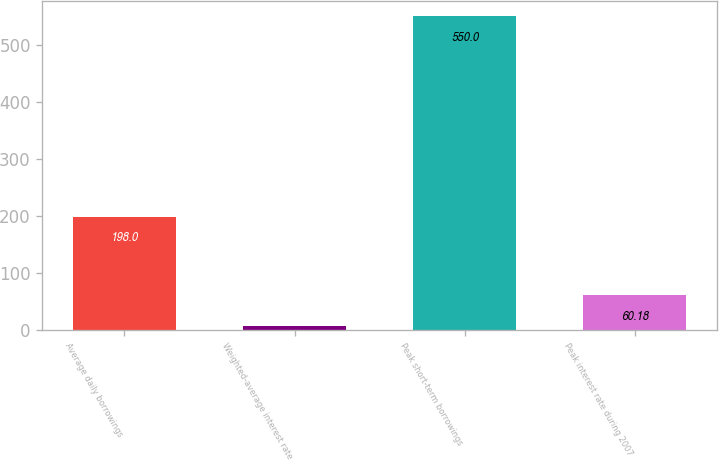<chart> <loc_0><loc_0><loc_500><loc_500><bar_chart><fcel>Average daily borrowings<fcel>Weighted-average interest rate<fcel>Peak short-term borrowings<fcel>Peak interest rate during 2007<nl><fcel>198<fcel>5.75<fcel>550<fcel>60.18<nl></chart> 